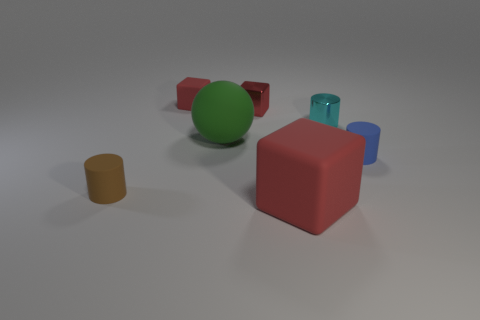Add 2 small red metallic cubes. How many objects exist? 9 Subtract all cylinders. How many objects are left? 4 Add 1 small cylinders. How many small cylinders are left? 4 Add 5 big cylinders. How many big cylinders exist? 5 Subtract 1 blue cylinders. How many objects are left? 6 Subtract all green blocks. Subtract all cyan metallic things. How many objects are left? 6 